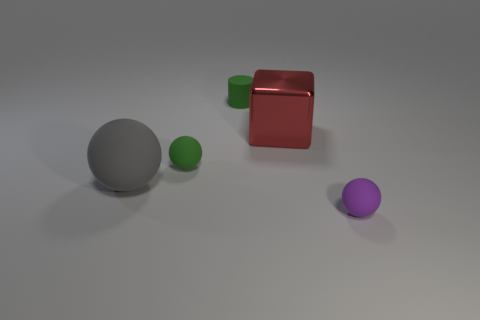Add 4 large gray matte objects. How many objects exist? 9 Subtract all big balls. How many balls are left? 2 Subtract all green spheres. How many spheres are left? 2 Subtract 1 blocks. How many blocks are left? 0 Add 2 small purple rubber balls. How many small purple rubber balls are left? 3 Add 5 purple rubber objects. How many purple rubber objects exist? 6 Subtract 1 green spheres. How many objects are left? 4 Subtract all cylinders. How many objects are left? 4 Subtract all gray spheres. Subtract all cyan blocks. How many spheres are left? 2 Subtract all green cubes. How many green balls are left? 1 